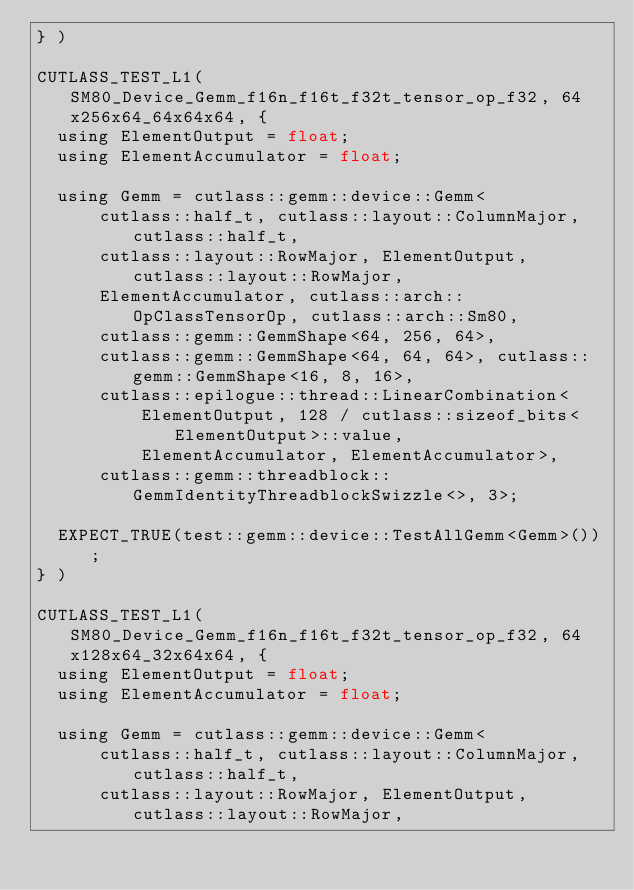Convert code to text. <code><loc_0><loc_0><loc_500><loc_500><_Cuda_>} )

CUTLASS_TEST_L1(SM80_Device_Gemm_f16n_f16t_f32t_tensor_op_f32, 64x256x64_64x64x64, {
  using ElementOutput = float;
  using ElementAccumulator = float;

  using Gemm = cutlass::gemm::device::Gemm<
      cutlass::half_t, cutlass::layout::ColumnMajor, cutlass::half_t,
      cutlass::layout::RowMajor, ElementOutput, cutlass::layout::RowMajor,
      ElementAccumulator, cutlass::arch::OpClassTensorOp, cutlass::arch::Sm80,
      cutlass::gemm::GemmShape<64, 256, 64>,
      cutlass::gemm::GemmShape<64, 64, 64>, cutlass::gemm::GemmShape<16, 8, 16>,
      cutlass::epilogue::thread::LinearCombination<
          ElementOutput, 128 / cutlass::sizeof_bits<ElementOutput>::value,
          ElementAccumulator, ElementAccumulator>,
      cutlass::gemm::threadblock::GemmIdentityThreadblockSwizzle<>, 3>;

  EXPECT_TRUE(test::gemm::device::TestAllGemm<Gemm>());
} )

CUTLASS_TEST_L1(SM80_Device_Gemm_f16n_f16t_f32t_tensor_op_f32, 64x128x64_32x64x64, {
  using ElementOutput = float;
  using ElementAccumulator = float;

  using Gemm = cutlass::gemm::device::Gemm<
      cutlass::half_t, cutlass::layout::ColumnMajor, cutlass::half_t,
      cutlass::layout::RowMajor, ElementOutput, cutlass::layout::RowMajor,</code> 